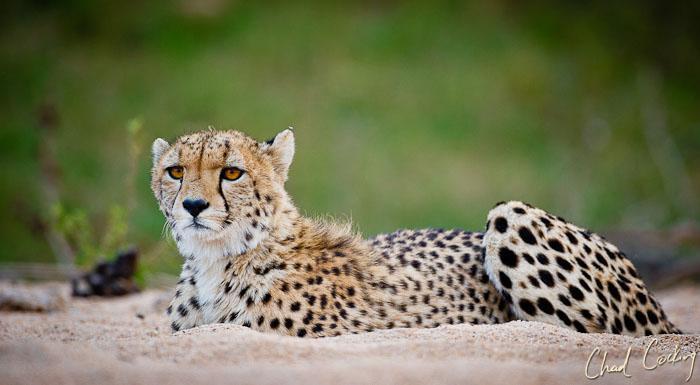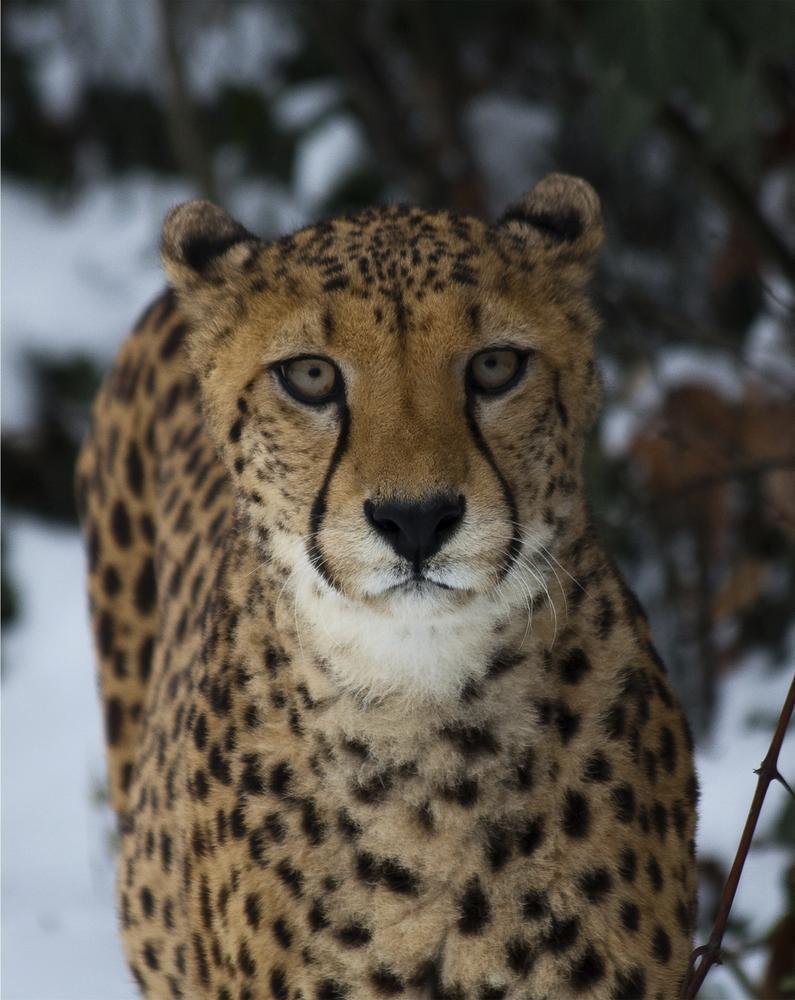The first image is the image on the left, the second image is the image on the right. Assess this claim about the two images: "All of the cheetahs are lying down.". Correct or not? Answer yes or no. No. 